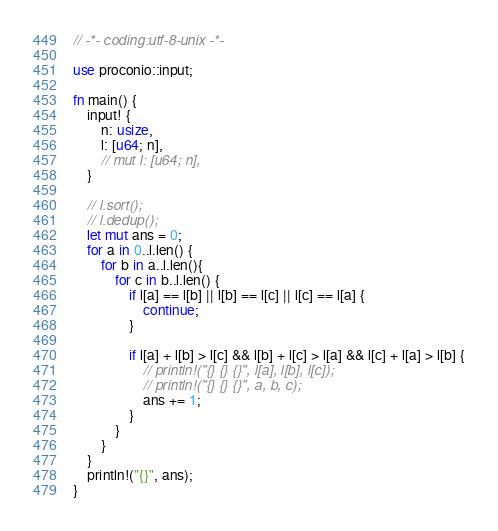Convert code to text. <code><loc_0><loc_0><loc_500><loc_500><_Rust_>// -*- coding:utf-8-unix -*-

use proconio::input;

fn main() {
    input! {
        n: usize,
        l: [u64; n],
        // mut l: [u64; n],
    }

    // l.sort();
    // l.dedup();
    let mut ans = 0;
    for a in 0..l.len() {
        for b in a..l.len(){
            for c in b..l.len() {
                if l[a] == l[b] || l[b] == l[c] || l[c] == l[a] {
                    continue;
                }

                if l[a] + l[b] > l[c] && l[b] + l[c] > l[a] && l[c] + l[a] > l[b] {
                    // println!("{} {} {}", l[a], l[b], l[c]);
                    // println!("{} {} {}", a, b, c);
                    ans += 1;
                }
            }
        }
    }
    println!("{}", ans);
}
</code> 